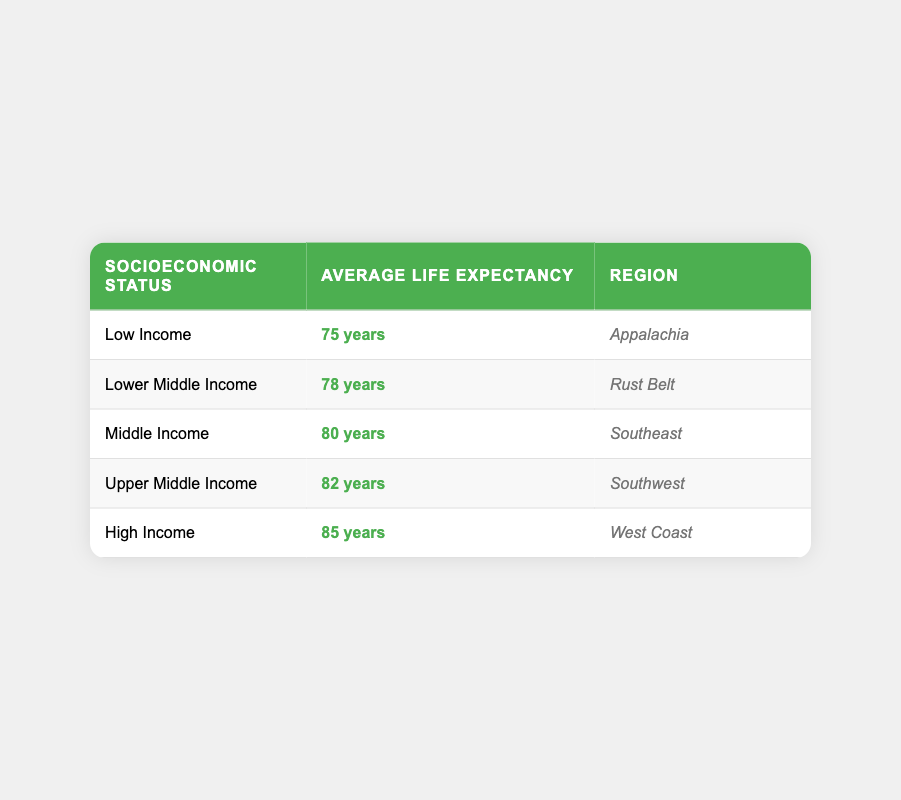What is the average life expectancy for those in low-income status? The table shows that the average life expectancy for low-income individuals is 75 years. This information can be found in the first row of the table under the "Average Life Expectancy" column for "Low Income."
Answer: 75 years Which socioeconomic status has the highest average life expectancy? The table indicates that the socioeconomic status with the highest average life expectancy is "High Income," with an average life expectancy of 85 years. This is listed in the last row of the table.
Answer: High Income What is the average life expectancy of individuals from the Southeast region? According to the table, individuals from the Southeast region fall under the "Middle Income" category, which has an average life expectancy of 80 years, as seen in the third row.
Answer: 80 years Is the average life expectancy for Upper Middle Income more than 80 years? The average life expectancy for Upper Middle Income, as per the table, is 82 years, which is indeed more than 80 years. This can be verified from the fourth row showing "Upper Middle Income" and its corresponding expectancy.
Answer: Yes What is the difference in average life expectancy between Low Income and High Income groups? The average life expectancy for Low Income is 75 years, and for High Income, it is 85 years. To find the difference, we subtract 75 from 85, resulting in a difference of 10 years. Hence, High Income individuals live, on average, 10 years longer than Low Income individuals.
Answer: 10 years Does the Rust Belt have a higher average life expectancy than Appalachia? The Rust Belt's average life expectancy is 78 years, while Appalachia's is 75 years according to the table. Since 78 is greater than 75, Rust Belt does have a higher average life expectancy than Appalachia.
Answer: Yes What is the average average life expectancy for all socioeconomic groups presented? To find the average for all groups, we add up the average life expectancies: 75 + 78 + 80 + 82 + 85 = 400. Then, we divide by the number of groups, which is 5: 400 / 5 = 80 years. Thus, the average life expectancy for all socioeconomic groups is 80 years.
Answer: 80 years Which regions correspond to Middle Income and Upper Middle Income? "Middle Income" corresponds to the "Southeast" region as per the table, while "Upper Middle Income" corresponds to the "Southwest" region. These can be found in the third and fourth rows respectively of the region column.
Answer: Southeast and Southwest 